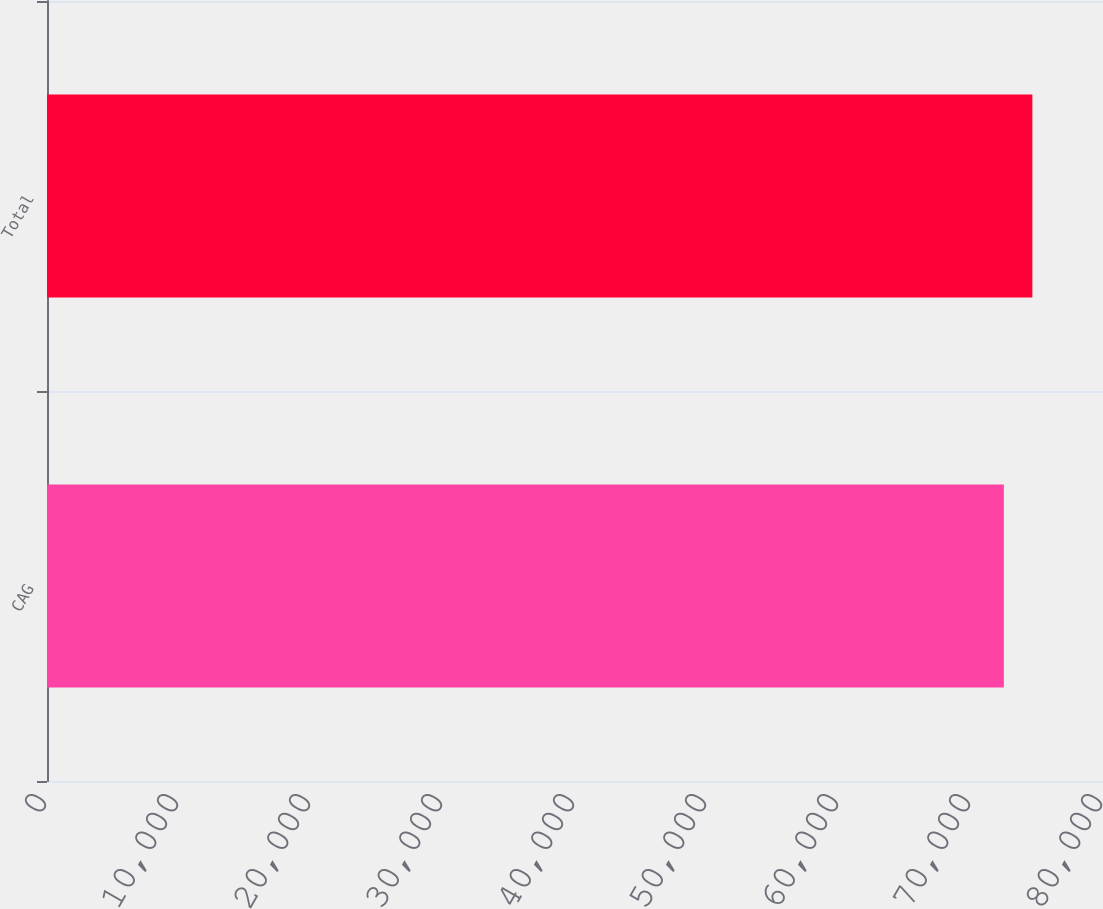Convert chart to OTSL. <chart><loc_0><loc_0><loc_500><loc_500><bar_chart><fcel>CAG<fcel>Total<nl><fcel>72489<fcel>74649<nl></chart> 